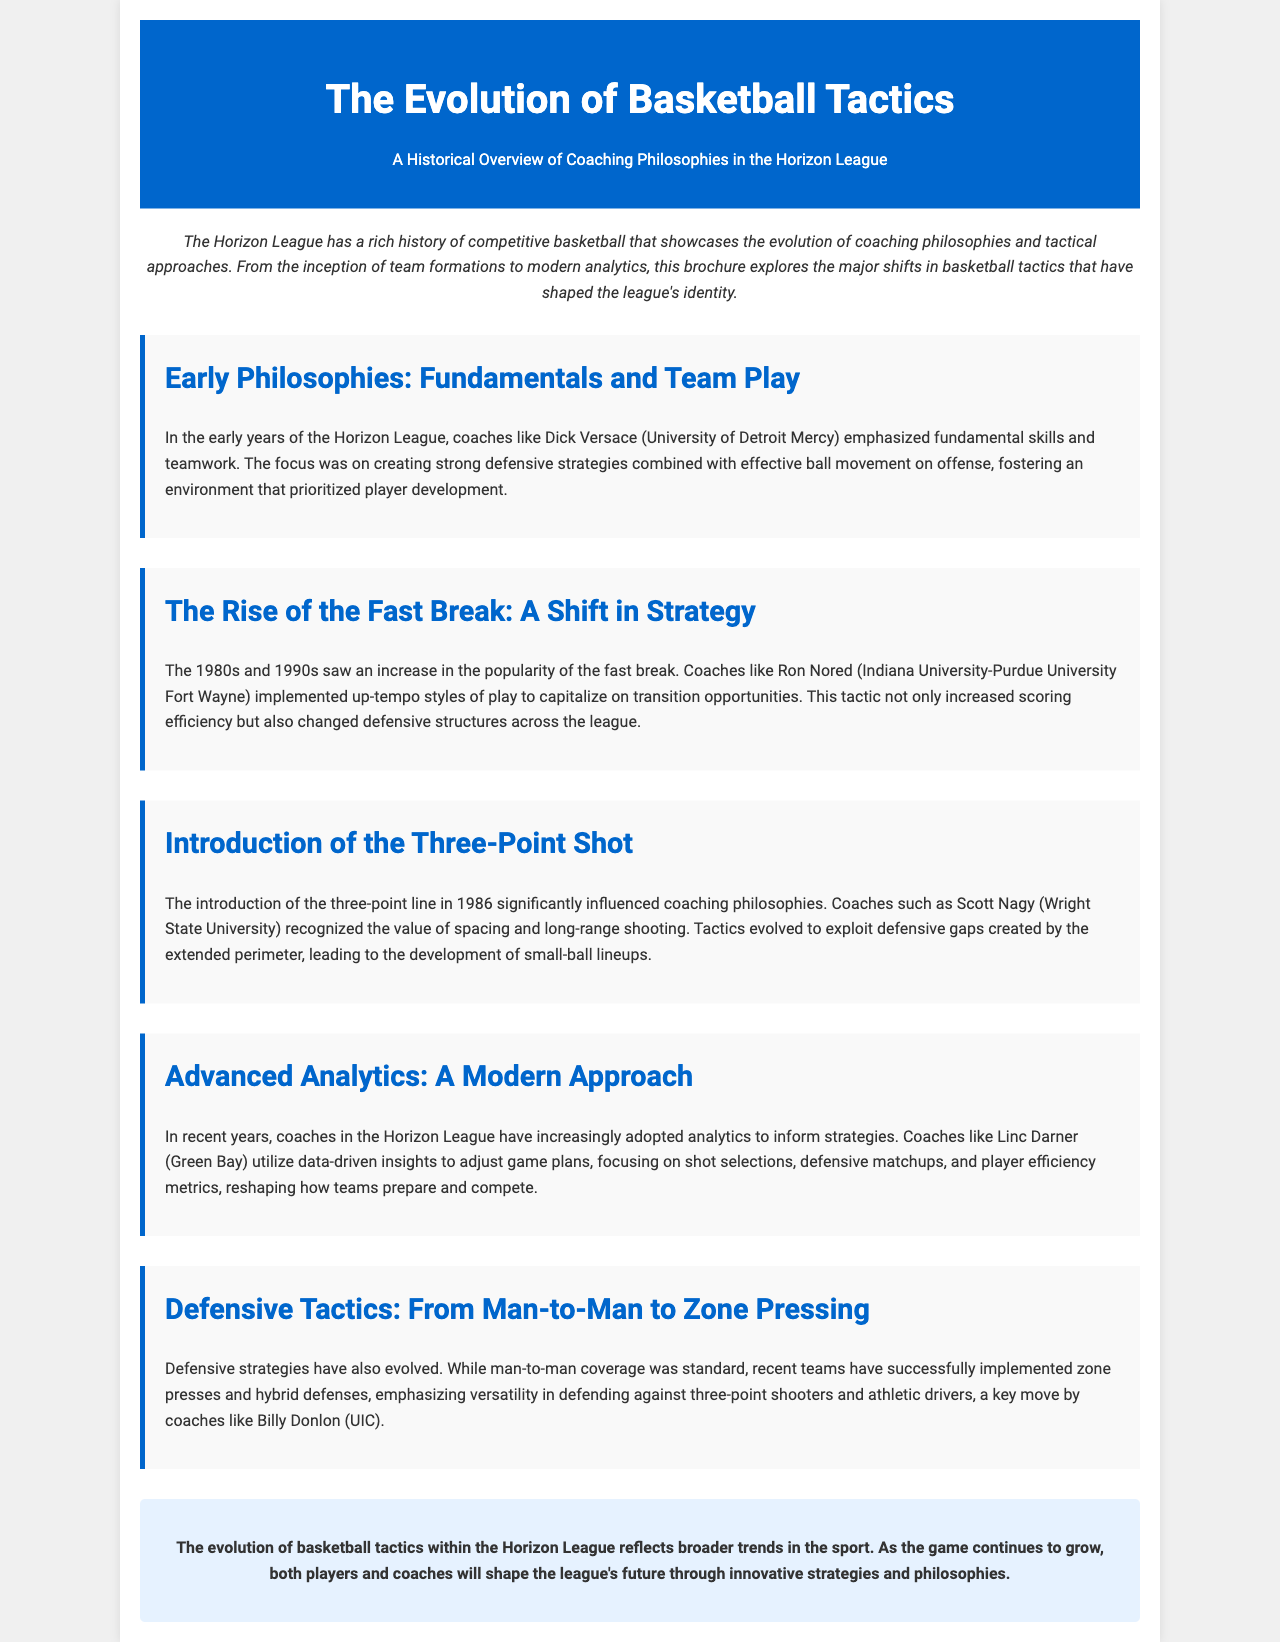What year did the three-point line get introduced? The document states that the three-point line was introduced in 1986, which influenced coaching philosophies.
Answer: 1986 Who emphasized fundamental skills and teamwork in early years? The text mentions Dick Versace from the University of Detroit Mercy as a coach who focused on fundamental skills and teamwork.
Answer: Dick Versace What tactic did Ron Nored implement in the 1980s and 1990s? The document describes that Ron Nored implemented an up-tempo style of play, capitalizing on fast breaks.
Answer: Fast break Which coach recognized the value of spacing and long-range shooting? According to the document, Scott Nagy from Wright State University recognized the value of spacing and long-range shooting with the introduction of the three-point shot.
Answer: Scott Nagy What defensive coverage was standard before the evolution mentioned? The document specifies that man-to-man coverage was the standard defensive strategy before the evolution of tactics.
Answer: Man-to-man Which coaching philosophy reflects broader trends in basketball? The document concludes that the evolution of basketball tactics in the Horizon League reflects broader trends in the sport.
Answer: Evolution of basketball tactics What is the focus of analytics in modern coaching? The text indicates that modern coaches focus on shot selections, defensive matchups, and player efficiency metrics through analytics.
Answer: Data-driven insights Which type of defense was successfully implemented by Billy Donlon? The document states that Billy Donlon implemented zone presses and hybrid defenses as successful defensive strategies.
Answer: Zone presses and hybrid defenses How does the brochure describe the Horizon League? The introduction describes the Horizon League as having a rich history of competitive basketball.
Answer: Rich history of competitive basketball 